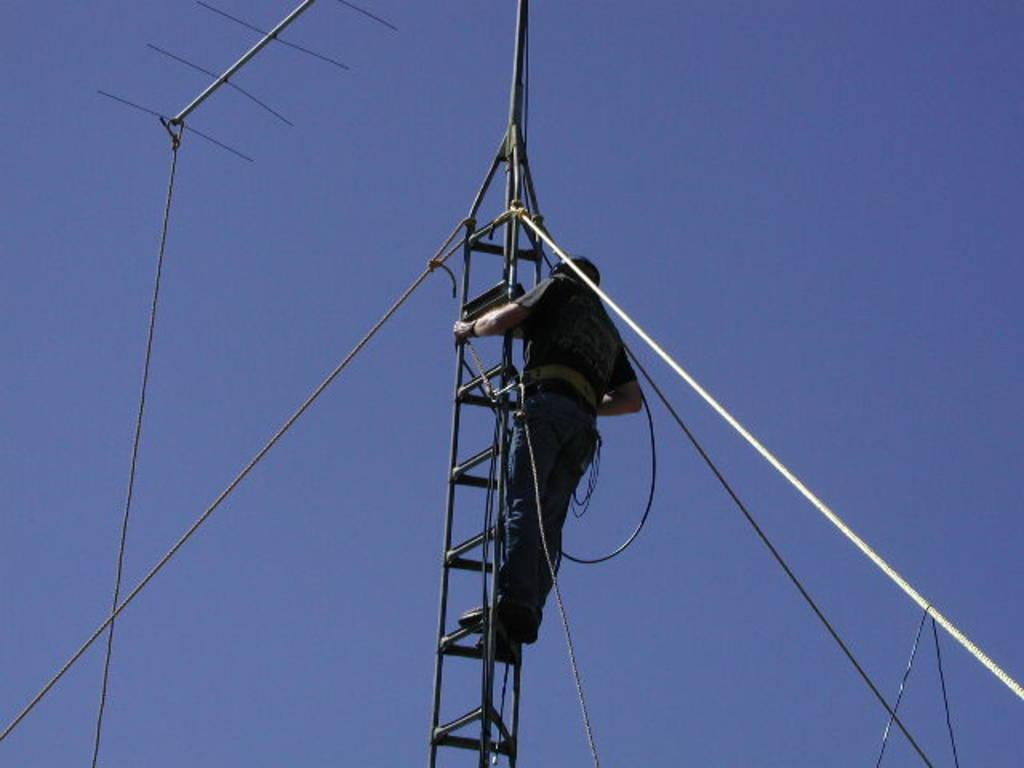What object can be seen in the image that is used for receiving signals? There is an antenna in the image. Can you describe the person in the image? There is a person in the image, but no specific details about their appearance or actions are provided. What is the person possibly using in the image? The person might be using a ladder, as it is visible in the image. What is the person possibly holding in the image? The person might be holding a rope, as it is visible in the image. What can be seen in the background of the image? The background of the image includes a blue sky. What type of help can be seen being provided by the queen in the image? There is no queen present in the image, and therefore no such help can be observed. What type of vein is visible in the image? There are no veins visible in the image; it features an antenna, a person, a ladder, a rope, and a blue sky. 